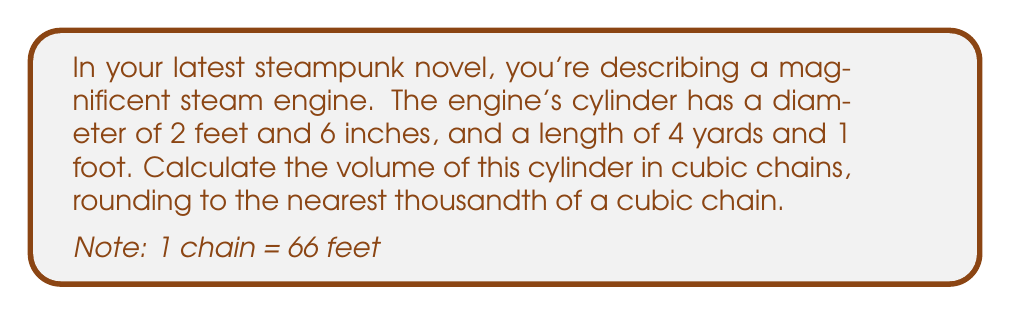Solve this math problem. To solve this problem, we'll follow these steps:

1) First, let's convert all measurements to feet:
   Diameter: 2 feet 6 inches = 2.5 feet
   Length: 4 yards 1 foot = (4 × 3) + 1 = 13 feet

2) Now we can calculate the radius:
   $r = \frac{diameter}{2} = \frac{2.5}{2} = 1.25$ feet

3) The volume of a cylinder is given by the formula:
   $V = \pi r^2 h$
   Where $r$ is the radius and $h$ is the height (length in this case)

4) Let's substitute our values:
   $V = \pi (1.25\text{ ft})^2 (13\text{ ft})$

5) Calculate:
   $V = \pi (1.5625\text{ ft}^2) (13\text{ ft})$
   $V = 20.3125\pi\text{ ft}^3$
   $V \approx 63.8052\text{ ft}^3$

6) Now we need to convert cubic feet to cubic chains:
   1 chain = 66 feet
   1 cubic chain = $66^3 = 287,496$ cubic feet

7) So, to convert cubic feet to cubic chains:
   $63.8052\text{ ft}^3 \div 287,496\text{ ft}^3/\text{chain}^3 \approx 0.000222\text{ chain}^3$

8) Rounding to the nearest thousandth of a cubic chain:
   $0.000\text{ chain}^3$
Answer: The volume of the steam engine's cylinder is approximately $0.000\text{ chain}^3$ (rounded to the nearest thousandth of a cubic chain). 